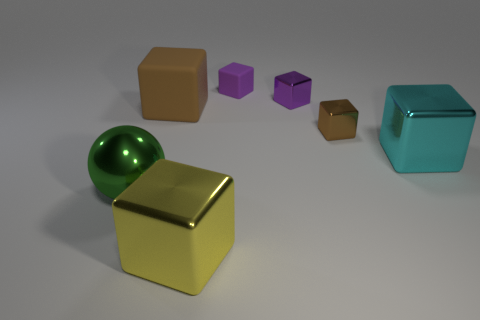What color is the other tiny metal object that is the same shape as the small purple metal object?
Offer a terse response. Brown. Is there anything else that has the same shape as the cyan thing?
Make the answer very short. Yes. Does the yellow shiny object have the same shape as the large shiny thing that is behind the large green shiny ball?
Your answer should be compact. Yes. What number of other objects are the same material as the large brown thing?
Ensure brevity in your answer.  1. There is a large rubber thing; does it have the same color as the tiny cube in front of the big brown rubber block?
Make the answer very short. Yes. There is a brown thing that is on the left side of the yellow shiny object; what is it made of?
Your response must be concise. Rubber. Are there any small metallic blocks that have the same color as the large matte object?
Your answer should be very brief. Yes. The matte block that is the same size as the green metal ball is what color?
Keep it short and to the point. Brown. How many big things are either cyan objects or yellow metal things?
Give a very brief answer. 2. Are there the same number of cubes left of the yellow block and green shiny objects behind the big green shiny object?
Provide a succinct answer. No. 